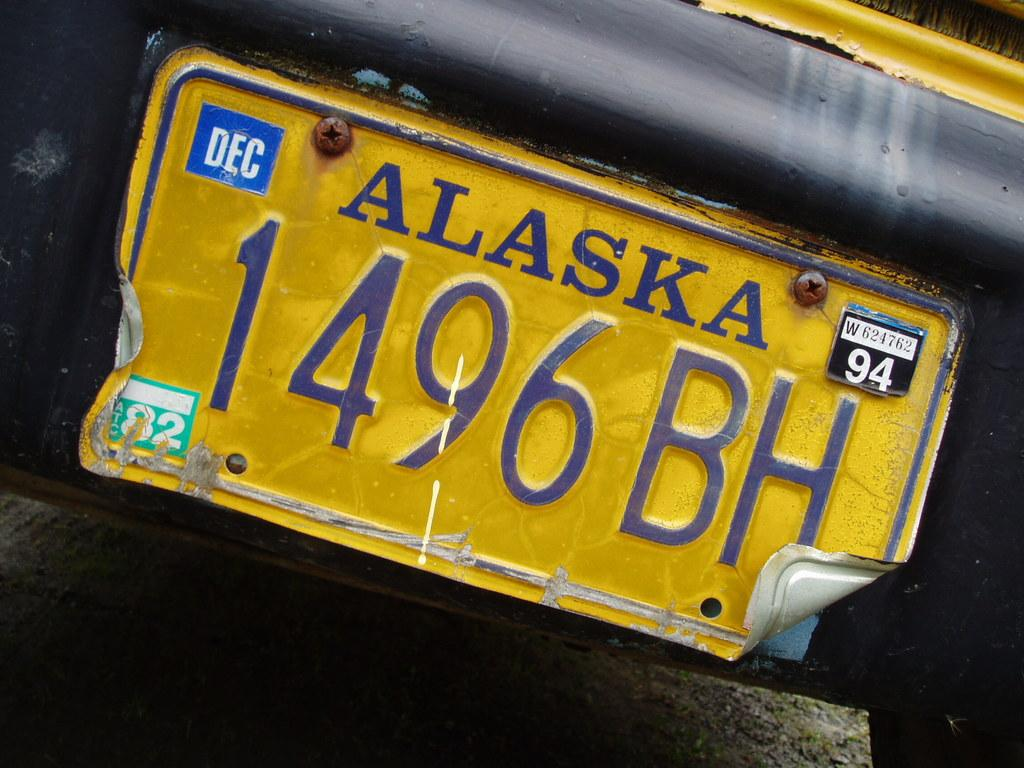<image>
Create a compact narrative representing the image presented. A yellow Alaska license plated with 1496 BH on it. 